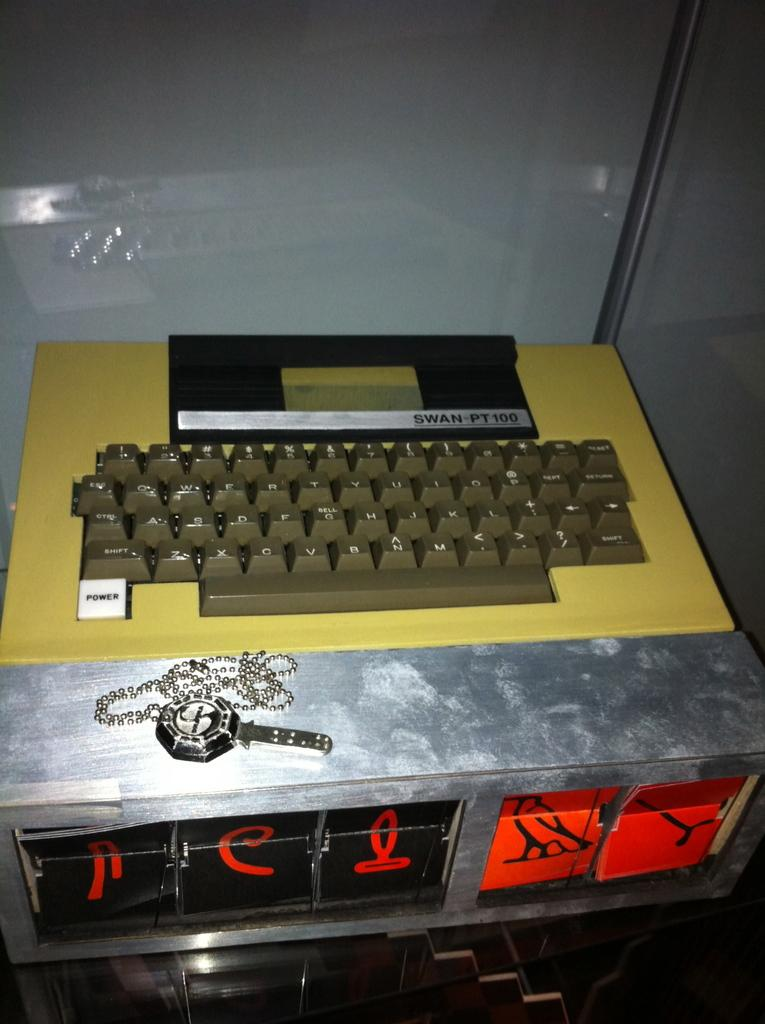<image>
Provide a brief description of the given image. A SWAN-PT100 had a grey keyboard with large keys. 